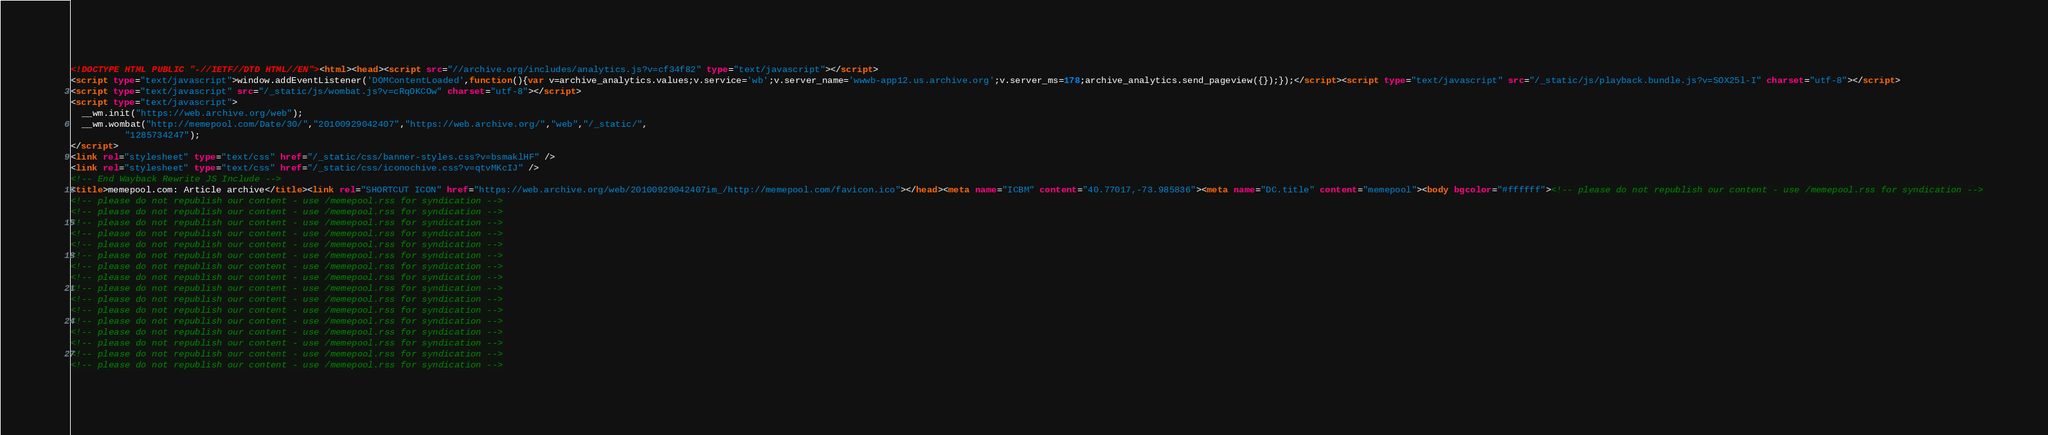Convert code to text. <code><loc_0><loc_0><loc_500><loc_500><_HTML_><!DOCTYPE HTML PUBLIC "-//IETF//DTD HTML//EN"><html><head><script src="//archive.org/includes/analytics.js?v=cf34f82" type="text/javascript"></script>
<script type="text/javascript">window.addEventListener('DOMContentLoaded',function(){var v=archive_analytics.values;v.service='wb';v.server_name='wwwb-app12.us.archive.org';v.server_ms=178;archive_analytics.send_pageview({});});</script><script type="text/javascript" src="/_static/js/playback.bundle.js?v=SOX25l-I" charset="utf-8"></script>
<script type="text/javascript" src="/_static/js/wombat.js?v=cRqOKCOw" charset="utf-8"></script>
<script type="text/javascript">
  __wm.init("https://web.archive.org/web");
  __wm.wombat("http://memepool.com/Date/30/","20100929042407","https://web.archive.org/","web","/_static/",
	      "1285734247");
</script>
<link rel="stylesheet" type="text/css" href="/_static/css/banner-styles.css?v=bsmaklHF" />
<link rel="stylesheet" type="text/css" href="/_static/css/iconochive.css?v=qtvMKcIJ" />
<!-- End Wayback Rewrite JS Include -->
<title>memepool.com: Article archive</title><link rel="SHORTCUT ICON" href="https://web.archive.org/web/20100929042407im_/http://memepool.com/favicon.ico"></head><meta name="ICBM" content="40.77017,-73.985836"><meta name="DC.title" content="memepool"><body bgcolor="#ffffff"><!-- please do not republish our content - use /memepool.rss for syndication -->
<!-- please do not republish our content - use /memepool.rss for syndication -->
<!-- please do not republish our content - use /memepool.rss for syndication -->
<!-- please do not republish our content - use /memepool.rss for syndication -->
<!-- please do not republish our content - use /memepool.rss for syndication -->
<!-- please do not republish our content - use /memepool.rss for syndication -->
<!-- please do not republish our content - use /memepool.rss for syndication -->
<!-- please do not republish our content - use /memepool.rss for syndication -->
<!-- please do not republish our content - use /memepool.rss for syndication -->
<!-- please do not republish our content - use /memepool.rss for syndication -->
<!-- please do not republish our content - use /memepool.rss for syndication -->
<!-- please do not republish our content - use /memepool.rss for syndication -->
<!-- please do not republish our content - use /memepool.rss for syndication -->
<!-- please do not republish our content - use /memepool.rss for syndication -->
<!-- please do not republish our content - use /memepool.rss for syndication -->
<!-- please do not republish our content - use /memepool.rss for syndication -->
<!-- please do not republish our content - use /memepool.rss for syndication --></code> 